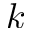Convert formula to latex. <formula><loc_0><loc_0><loc_500><loc_500>k</formula> 